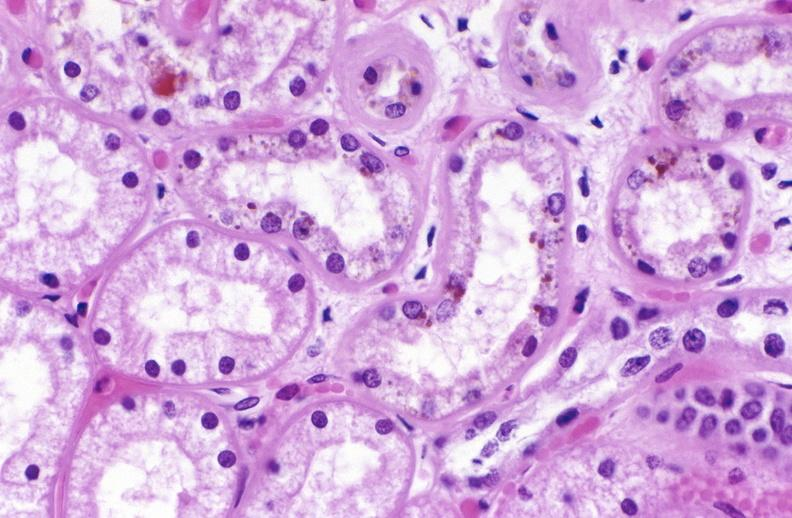s urinary present?
Answer the question using a single word or phrase. Yes 